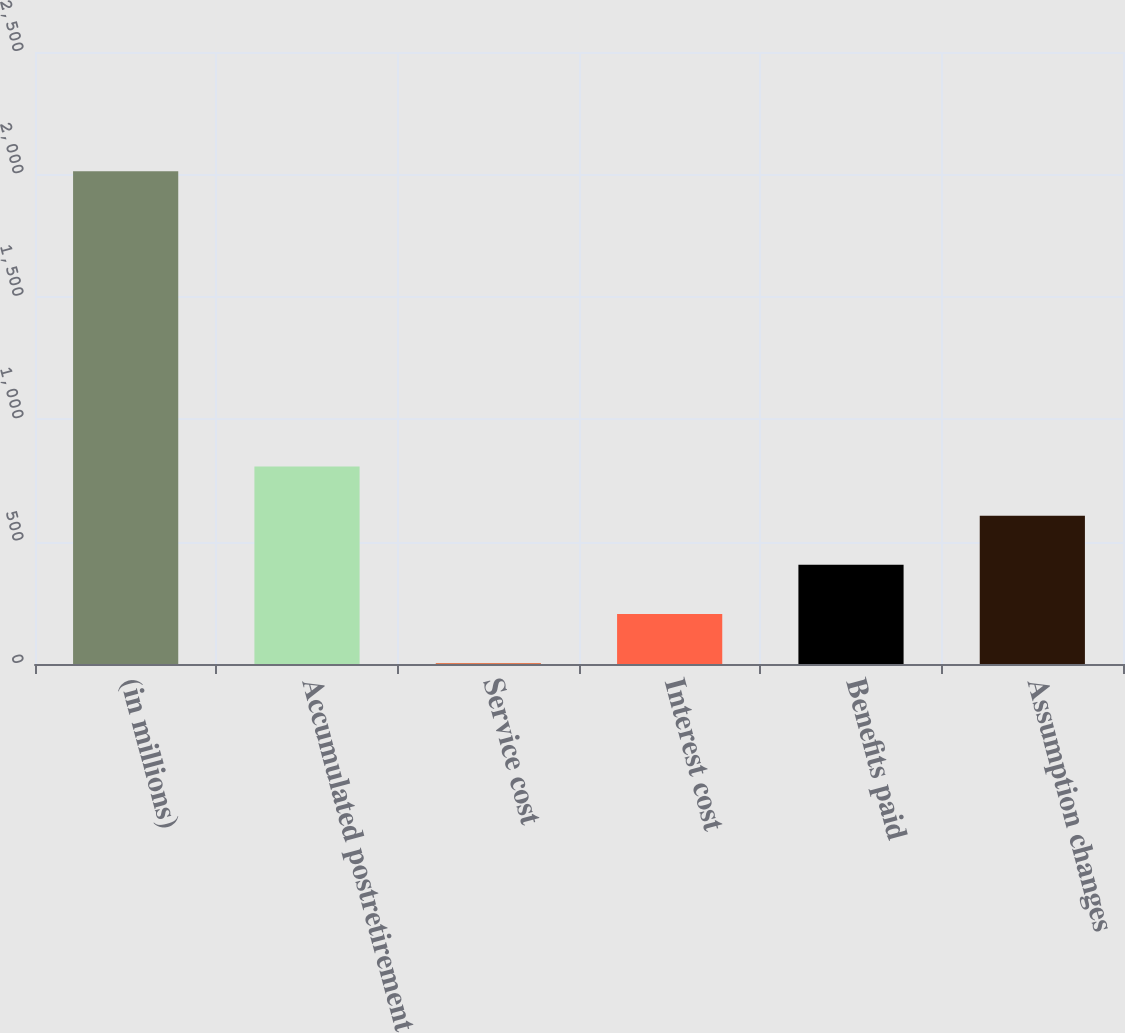Convert chart. <chart><loc_0><loc_0><loc_500><loc_500><bar_chart><fcel>(in millions)<fcel>Accumulated postretirement<fcel>Service cost<fcel>Interest cost<fcel>Benefits paid<fcel>Assumption changes<nl><fcel>2013<fcel>807<fcel>3<fcel>204<fcel>405<fcel>606<nl></chart> 